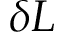Convert formula to latex. <formula><loc_0><loc_0><loc_500><loc_500>\delta L</formula> 